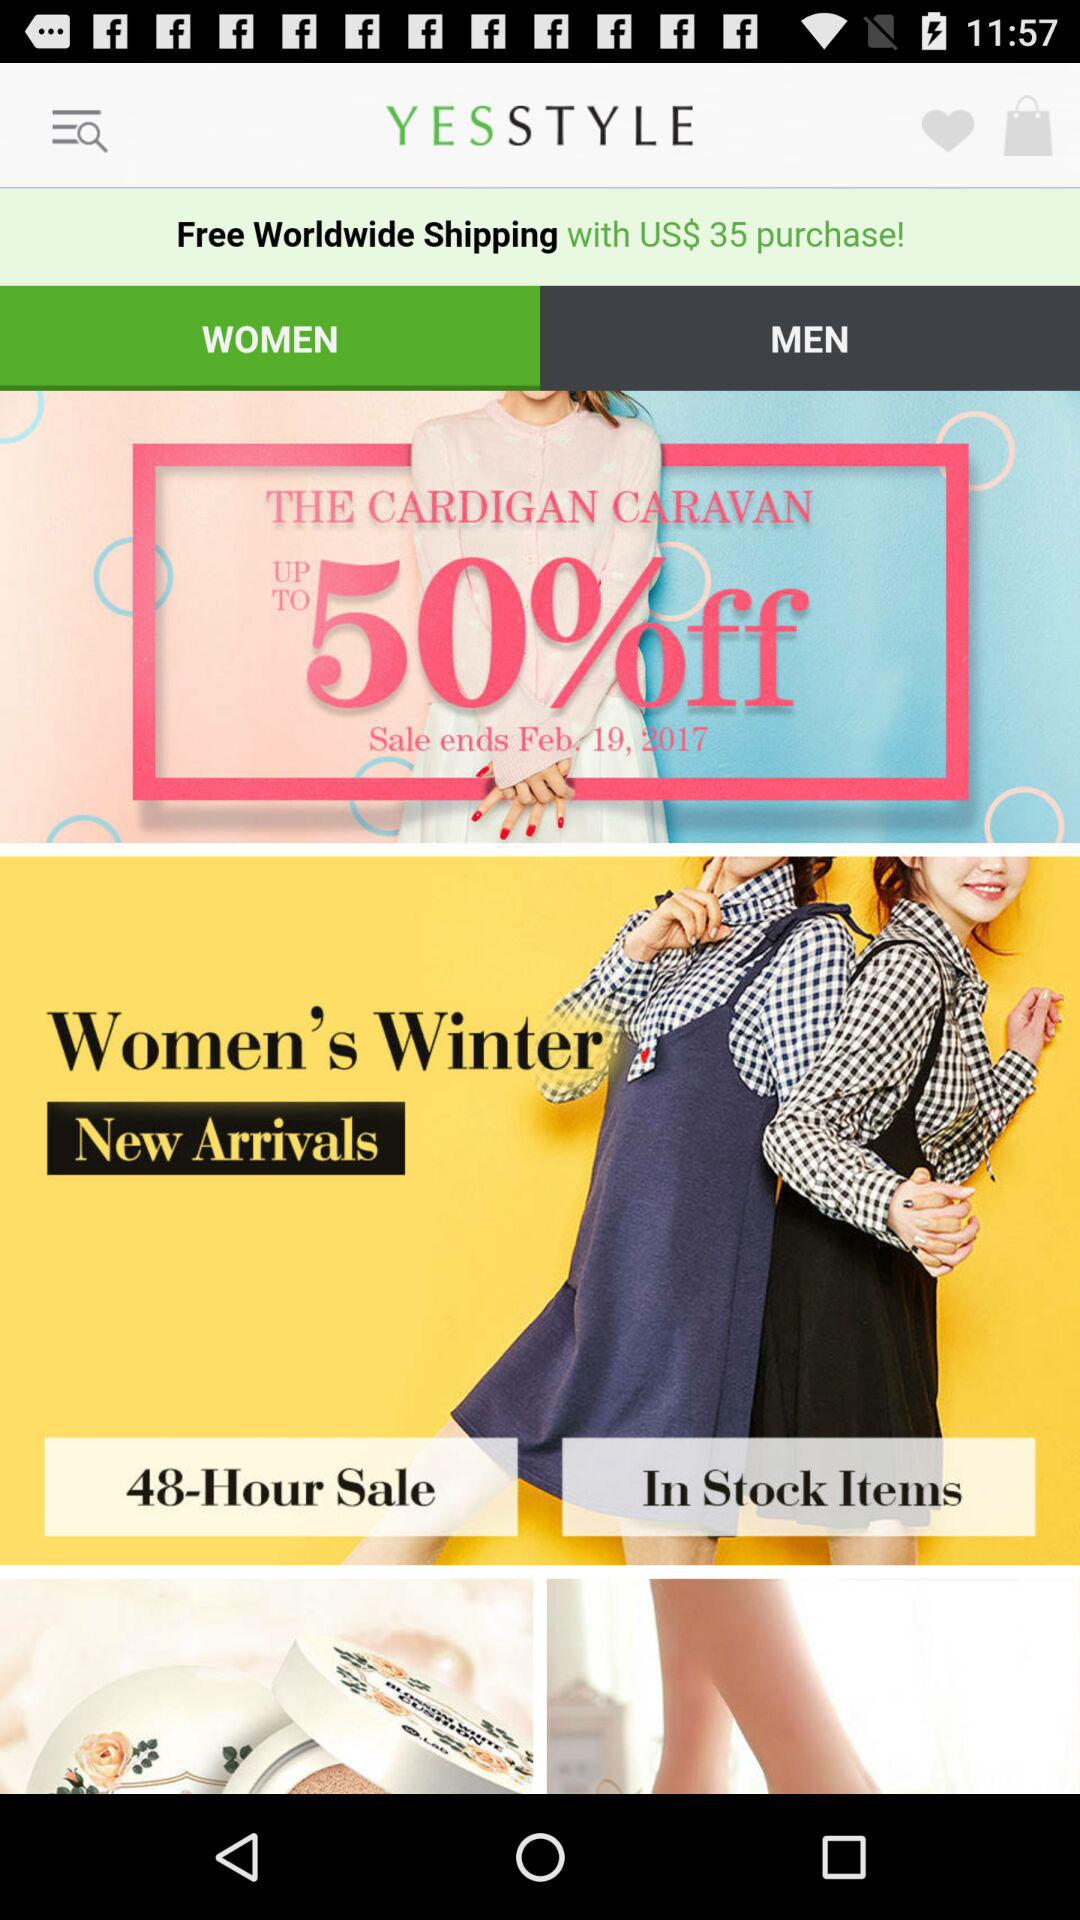Which gender has been selected? The selected gender is women. 